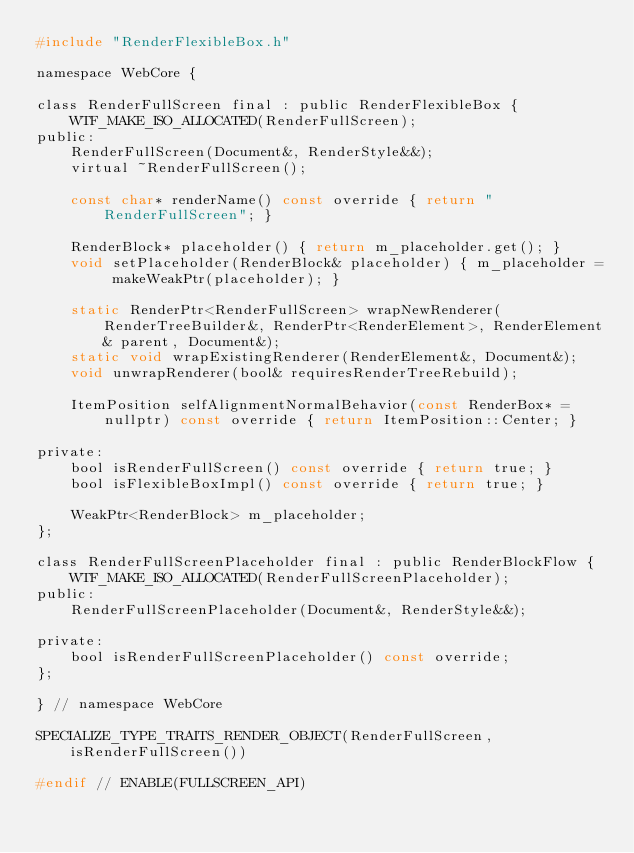<code> <loc_0><loc_0><loc_500><loc_500><_C_>#include "RenderFlexibleBox.h"

namespace WebCore {

class RenderFullScreen final : public RenderFlexibleBox {
    WTF_MAKE_ISO_ALLOCATED(RenderFullScreen);
public:
    RenderFullScreen(Document&, RenderStyle&&);
    virtual ~RenderFullScreen();

    const char* renderName() const override { return "RenderFullScreen"; }

    RenderBlock* placeholder() { return m_placeholder.get(); }
    void setPlaceholder(RenderBlock& placeholder) { m_placeholder = makeWeakPtr(placeholder); }

    static RenderPtr<RenderFullScreen> wrapNewRenderer(RenderTreeBuilder&, RenderPtr<RenderElement>, RenderElement& parent, Document&);
    static void wrapExistingRenderer(RenderElement&, Document&);
    void unwrapRenderer(bool& requiresRenderTreeRebuild);

    ItemPosition selfAlignmentNormalBehavior(const RenderBox* = nullptr) const override { return ItemPosition::Center; }
    
private:
    bool isRenderFullScreen() const override { return true; }
    bool isFlexibleBoxImpl() const override { return true; }

    WeakPtr<RenderBlock> m_placeholder;
};

class RenderFullScreenPlaceholder final : public RenderBlockFlow {
    WTF_MAKE_ISO_ALLOCATED(RenderFullScreenPlaceholder);
public:
    RenderFullScreenPlaceholder(Document&, RenderStyle&&);

private:
    bool isRenderFullScreenPlaceholder() const override;
};

} // namespace WebCore

SPECIALIZE_TYPE_TRAITS_RENDER_OBJECT(RenderFullScreen, isRenderFullScreen())

#endif // ENABLE(FULLSCREEN_API)
</code> 